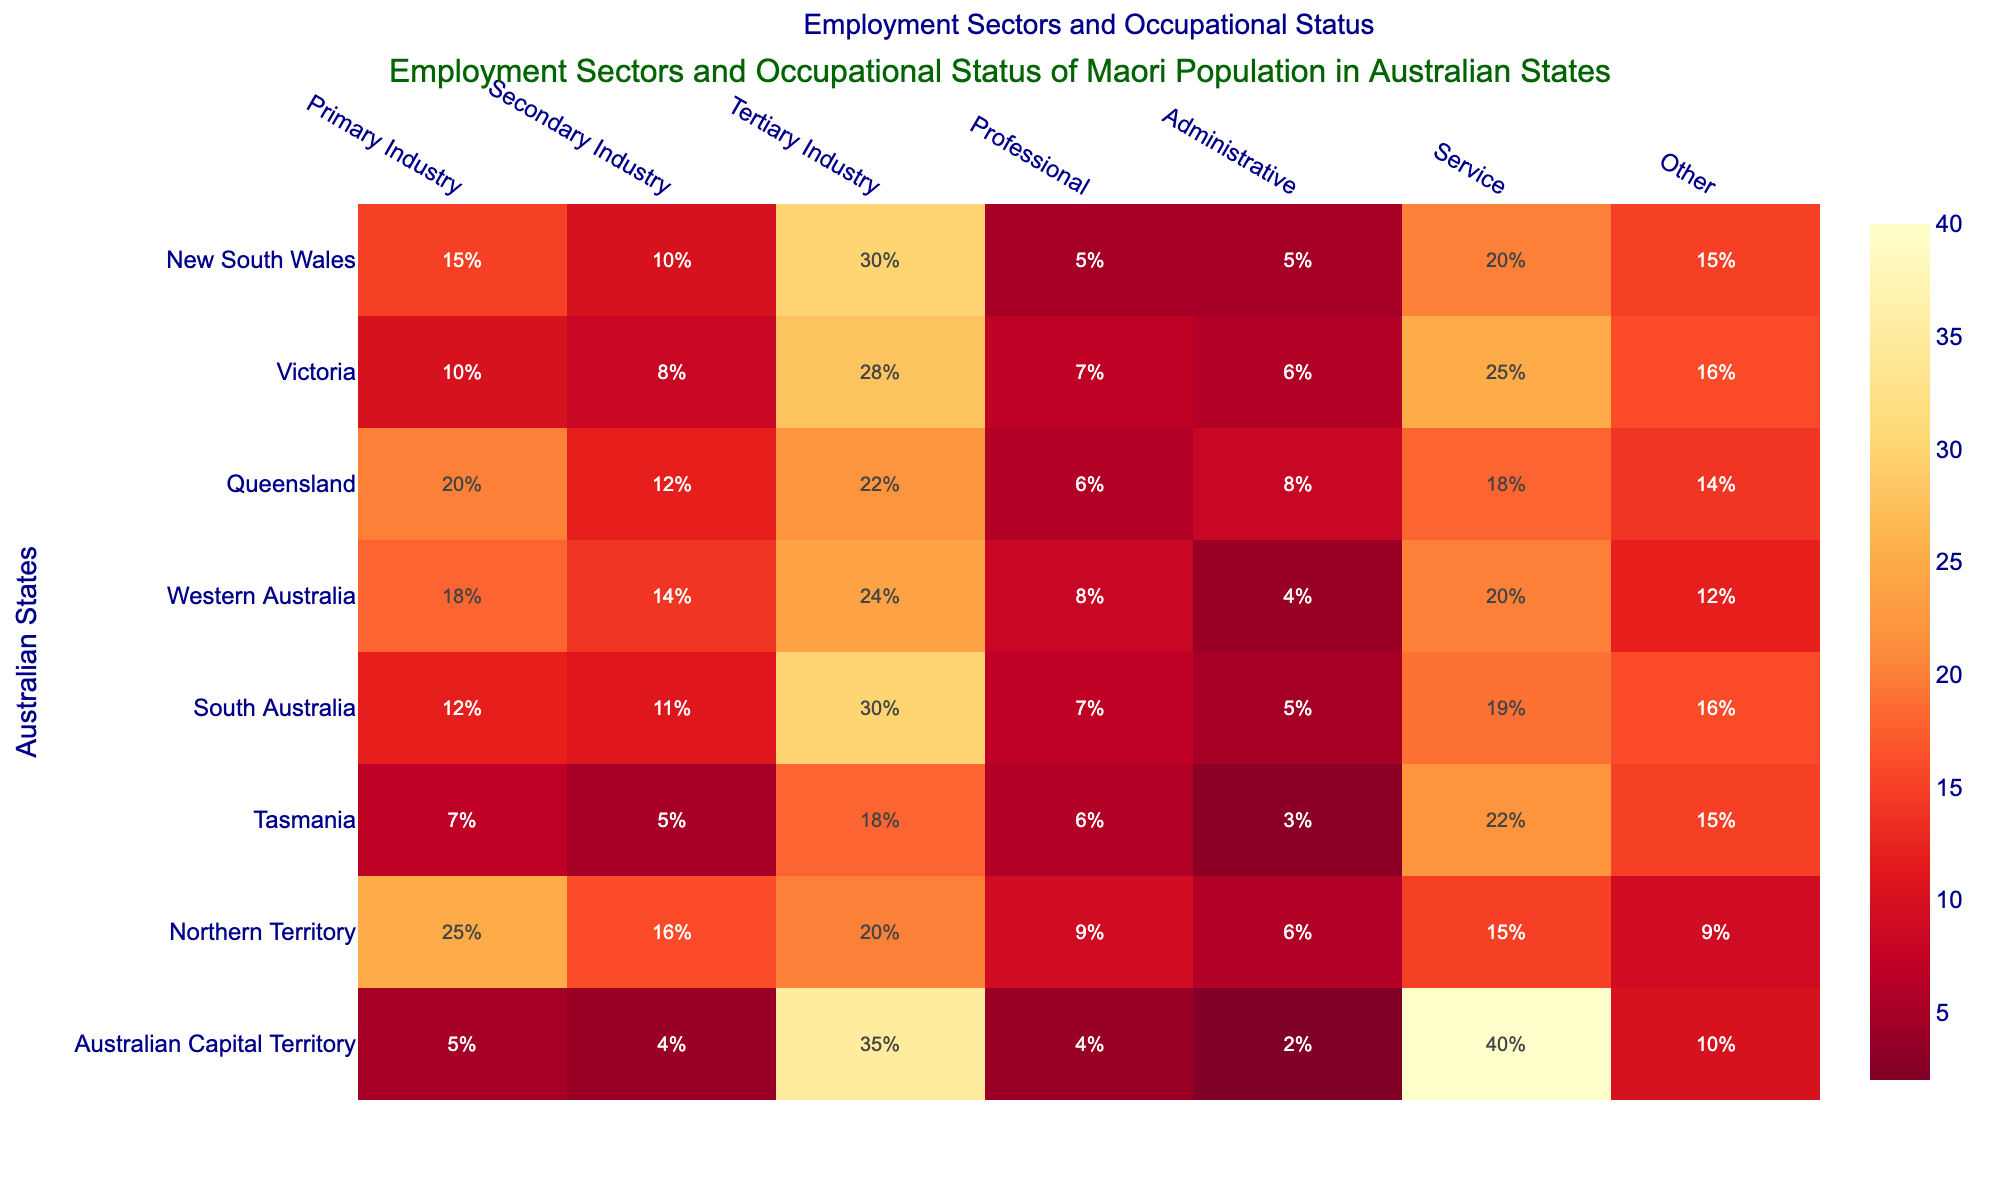what is the title of the heatmap? The title appears at the top of the heatmap, clearly written as the main heading of the chart.
Answer: Employment Sectors and Occupational Status of Maori Population in Australian States Which state has the highest percentage in the Primary Industry category? Looking at the Primary Industry column in the heatmap and locating the highest value visually.
Answer: Northern Territory How many states have a percentage of 30% or more in the Tertiary Industry sector? Check the Tertiary Industry column and count the states with values equal to or greater than 30.
Answer: 3 Which two states have the same percentage in the Administrative sector? Compare the values under the Administrative category and identify the states with the same value.
Answer: New South Wales and South Australia What's the sum of the percentages for Primary Industry and Professional categories in Queensland? Add the value of Primary Industry (20) and Professional (6) in the Queensland row.
Answer: 26 Which state has the highest percentage in the Service sector, and what is the percentage? Look for the highest value in the Service category column and identify the corresponding state and value.
Answer: Australian Capital Territory, 40 Compare New South Wales and Victoria in terms of Secondary Industry and Professional sectors. In which sector do they differ the most and by how much? Calculate the difference for both sectors: Secondary Industry (10 - 8 = 2) and Professional (5 - 7 = 2). They differ the most in the Professional sector by 2.
Answer: Professional, 2 What is the average percentage of the Administrative sector across all states? Add the percentages for the Administrative sector (5+6+8+4+5+3+6+2 = 39) and divide by the number of states (8).
Answer: 4.875 Which sector has the highest variation in the percentages across all states? Calculate variations by observing the range (difference between max and min values) in each column, identifying the highest range visually.
Answer: Service In which state is the percentage of the Other category the lowest, and what is the value? Locate the visually smallest number in the Other column and note the corresponding state and value.
Answer: Northern Territory, 9 